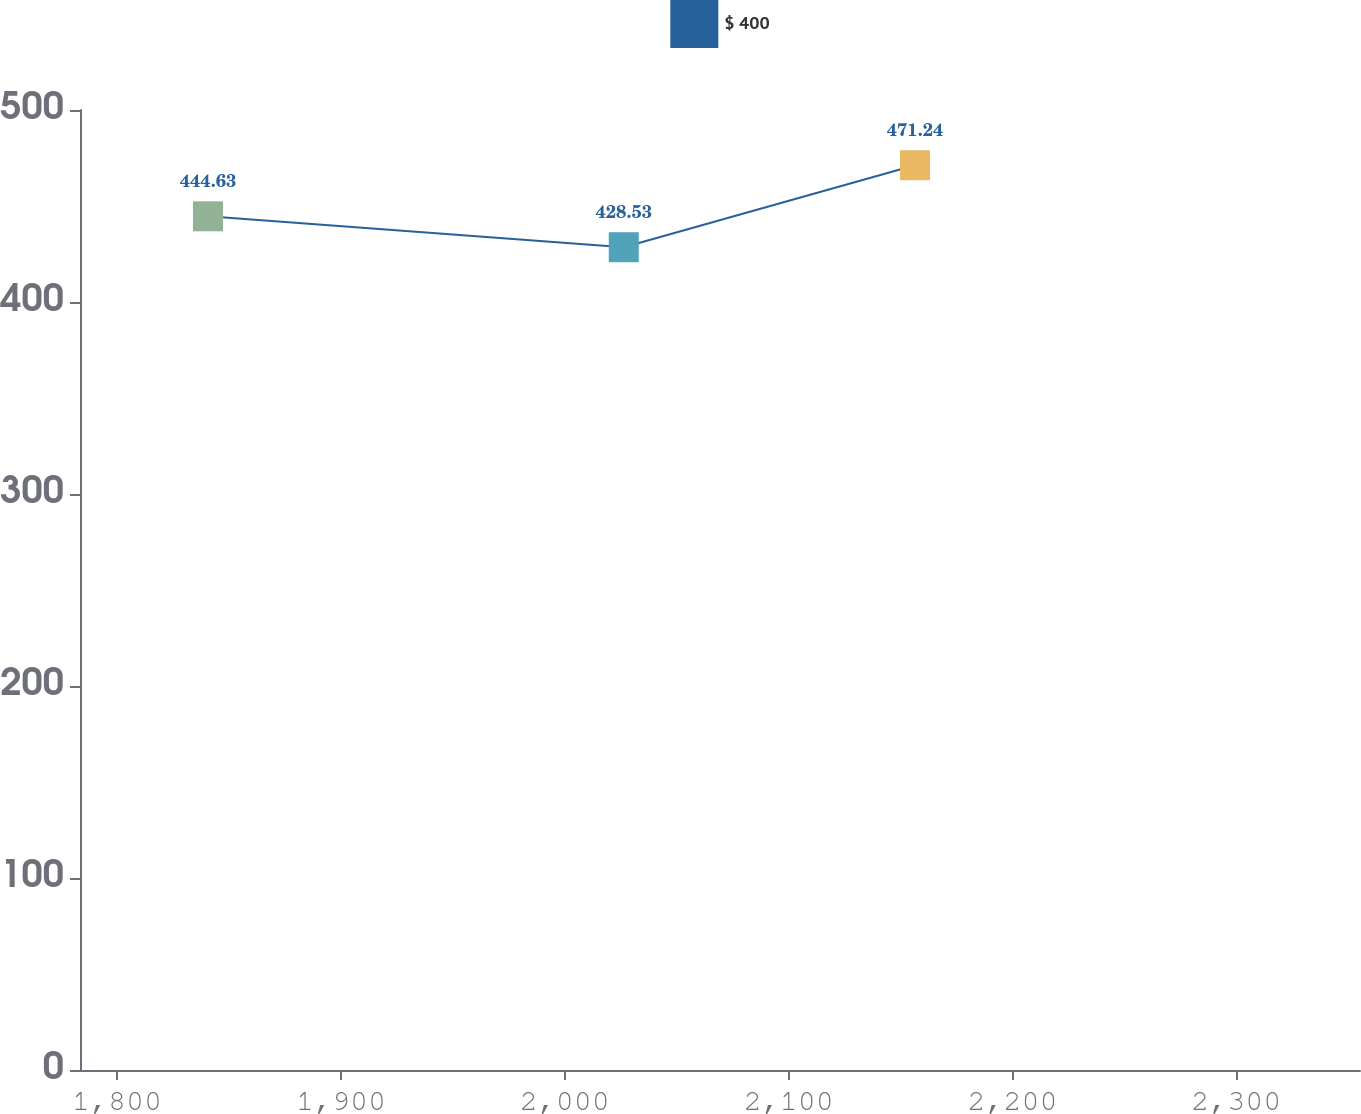Convert chart. <chart><loc_0><loc_0><loc_500><loc_500><line_chart><ecel><fcel>$ 400<nl><fcel>1840.6<fcel>444.63<nl><fcel>2026.33<fcel>428.53<nl><fcel>2156.43<fcel>471.24<nl><fcel>2412.41<fcel>504.85<nl></chart> 